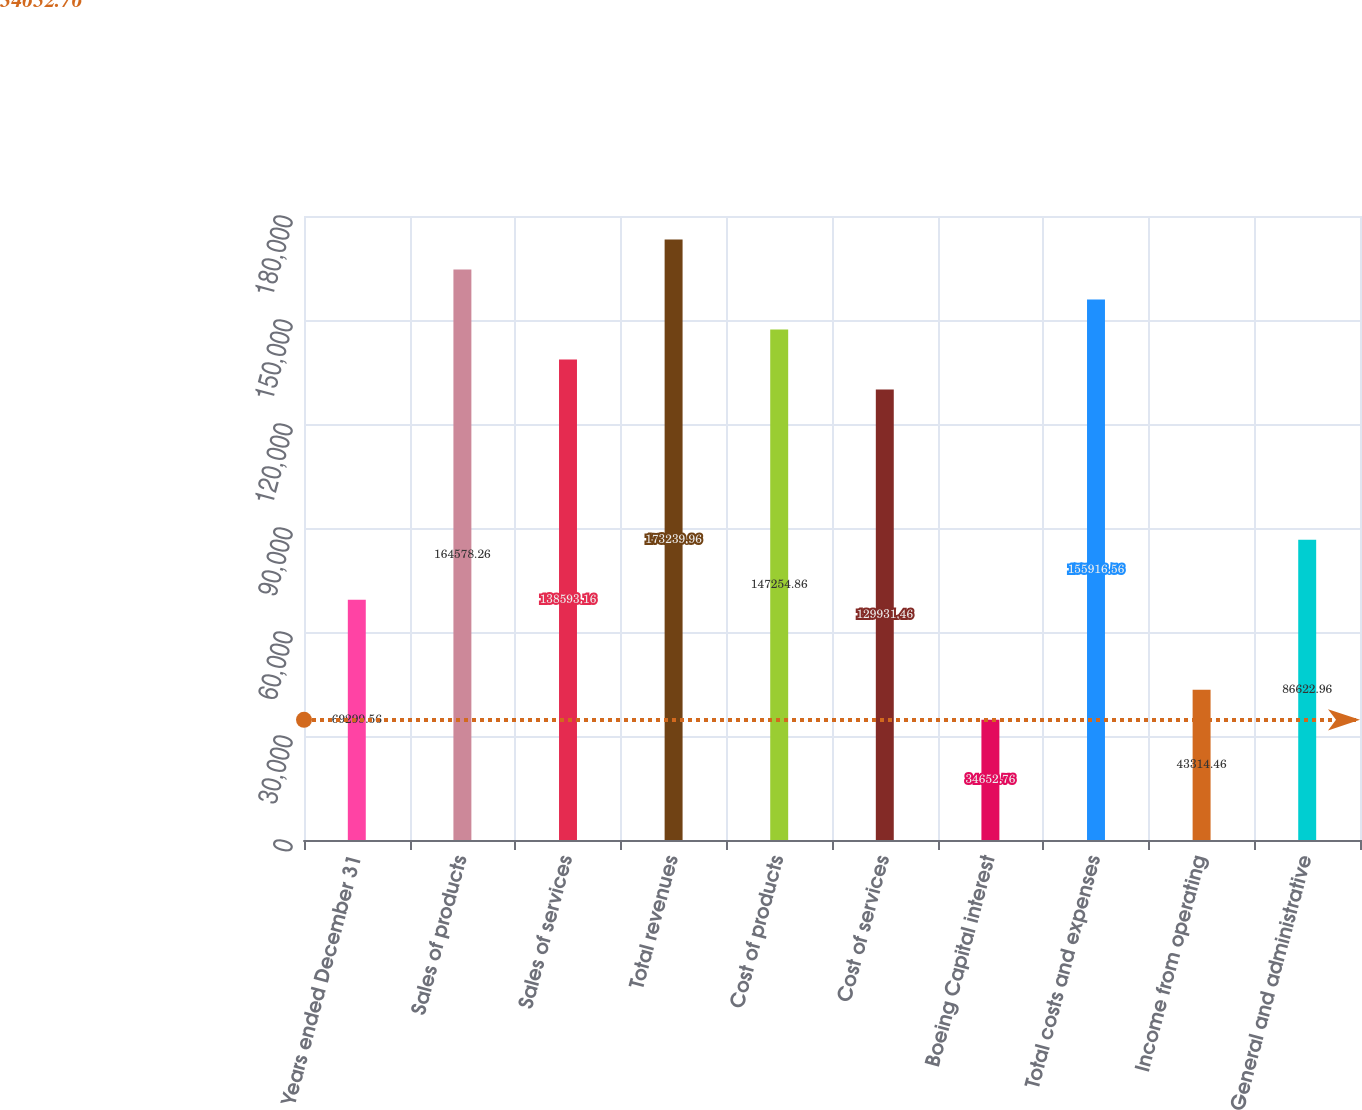<chart> <loc_0><loc_0><loc_500><loc_500><bar_chart><fcel>Years ended December 31<fcel>Sales of products<fcel>Sales of services<fcel>Total revenues<fcel>Cost of products<fcel>Cost of services<fcel>Boeing Capital interest<fcel>Total costs and expenses<fcel>Income from operating<fcel>General and administrative<nl><fcel>69299.6<fcel>164578<fcel>138593<fcel>173240<fcel>147255<fcel>129931<fcel>34652.8<fcel>155917<fcel>43314.5<fcel>86623<nl></chart> 